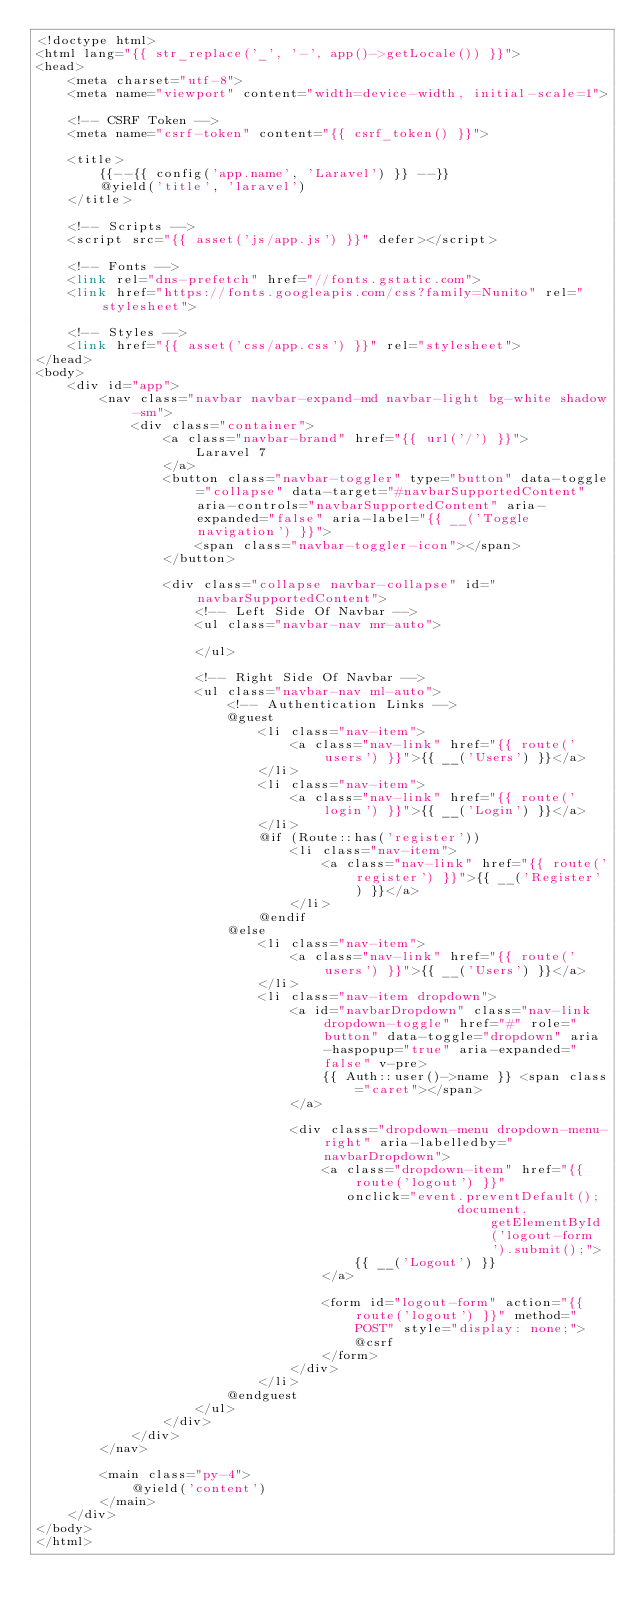<code> <loc_0><loc_0><loc_500><loc_500><_PHP_><!doctype html>
<html lang="{{ str_replace('_', '-', app()->getLocale()) }}">
<head>
    <meta charset="utf-8">
    <meta name="viewport" content="width=device-width, initial-scale=1">

    <!-- CSRF Token -->
    <meta name="csrf-token" content="{{ csrf_token() }}">

    <title>
        {{--{{ config('app.name', 'Laravel') }} --}}
        @yield('title', 'laravel')
    </title>

    <!-- Scripts -->
    <script src="{{ asset('js/app.js') }}" defer></script>

    <!-- Fonts -->
    <link rel="dns-prefetch" href="//fonts.gstatic.com">
    <link href="https://fonts.googleapis.com/css?family=Nunito" rel="stylesheet">

    <!-- Styles -->
    <link href="{{ asset('css/app.css') }}" rel="stylesheet">
</head>
<body>
    <div id="app">
        <nav class="navbar navbar-expand-md navbar-light bg-white shadow-sm">
            <div class="container">
                <a class="navbar-brand" href="{{ url('/') }}">
                    Laravel 7
                </a>
                <button class="navbar-toggler" type="button" data-toggle="collapse" data-target="#navbarSupportedContent" aria-controls="navbarSupportedContent" aria-expanded="false" aria-label="{{ __('Toggle navigation') }}">
                    <span class="navbar-toggler-icon"></span>
                </button>

                <div class="collapse navbar-collapse" id="navbarSupportedContent">
                    <!-- Left Side Of Navbar -->
                    <ul class="navbar-nav mr-auto">

                    </ul>

                    <!-- Right Side Of Navbar -->
                    <ul class="navbar-nav ml-auto">
                        <!-- Authentication Links -->
                        @guest
                            <li class="nav-item">
                                <a class="nav-link" href="{{ route('users') }}">{{ __('Users') }}</a>
                            </li>
                            <li class="nav-item">
                                <a class="nav-link" href="{{ route('login') }}">{{ __('Login') }}</a>
                            </li>
                            @if (Route::has('register'))
                                <li class="nav-item">
                                    <a class="nav-link" href="{{ route('register') }}">{{ __('Register') }}</a>
                                </li>
                            @endif
                        @else
                            <li class="nav-item">
                                <a class="nav-link" href="{{ route('users') }}">{{ __('Users') }}</a>
                            </li>
                            <li class="nav-item dropdown">
                                <a id="navbarDropdown" class="nav-link dropdown-toggle" href="#" role="button" data-toggle="dropdown" aria-haspopup="true" aria-expanded="false" v-pre>
                                    {{ Auth::user()->name }} <span class="caret"></span>
                                </a>

                                <div class="dropdown-menu dropdown-menu-right" aria-labelledby="navbarDropdown">
                                    <a class="dropdown-item" href="{{ route('logout') }}"
                                       onclick="event.preventDefault();
                                                     document.getElementById('logout-form').submit();">
                                        {{ __('Logout') }}
                                    </a>

                                    <form id="logout-form" action="{{ route('logout') }}" method="POST" style="display: none;">
                                        @csrf
                                    </form>
                                </div>
                            </li>
                        @endguest
                    </ul>
                </div>
            </div>
        </nav>

        <main class="py-4">
            @yield('content')
        </main>
    </div>
</body>
</html>
</code> 